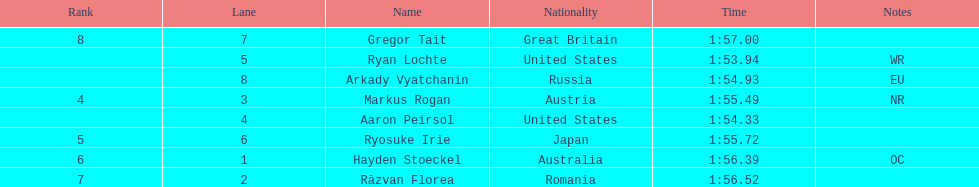Does russia or japan have the longer time? Japan. 